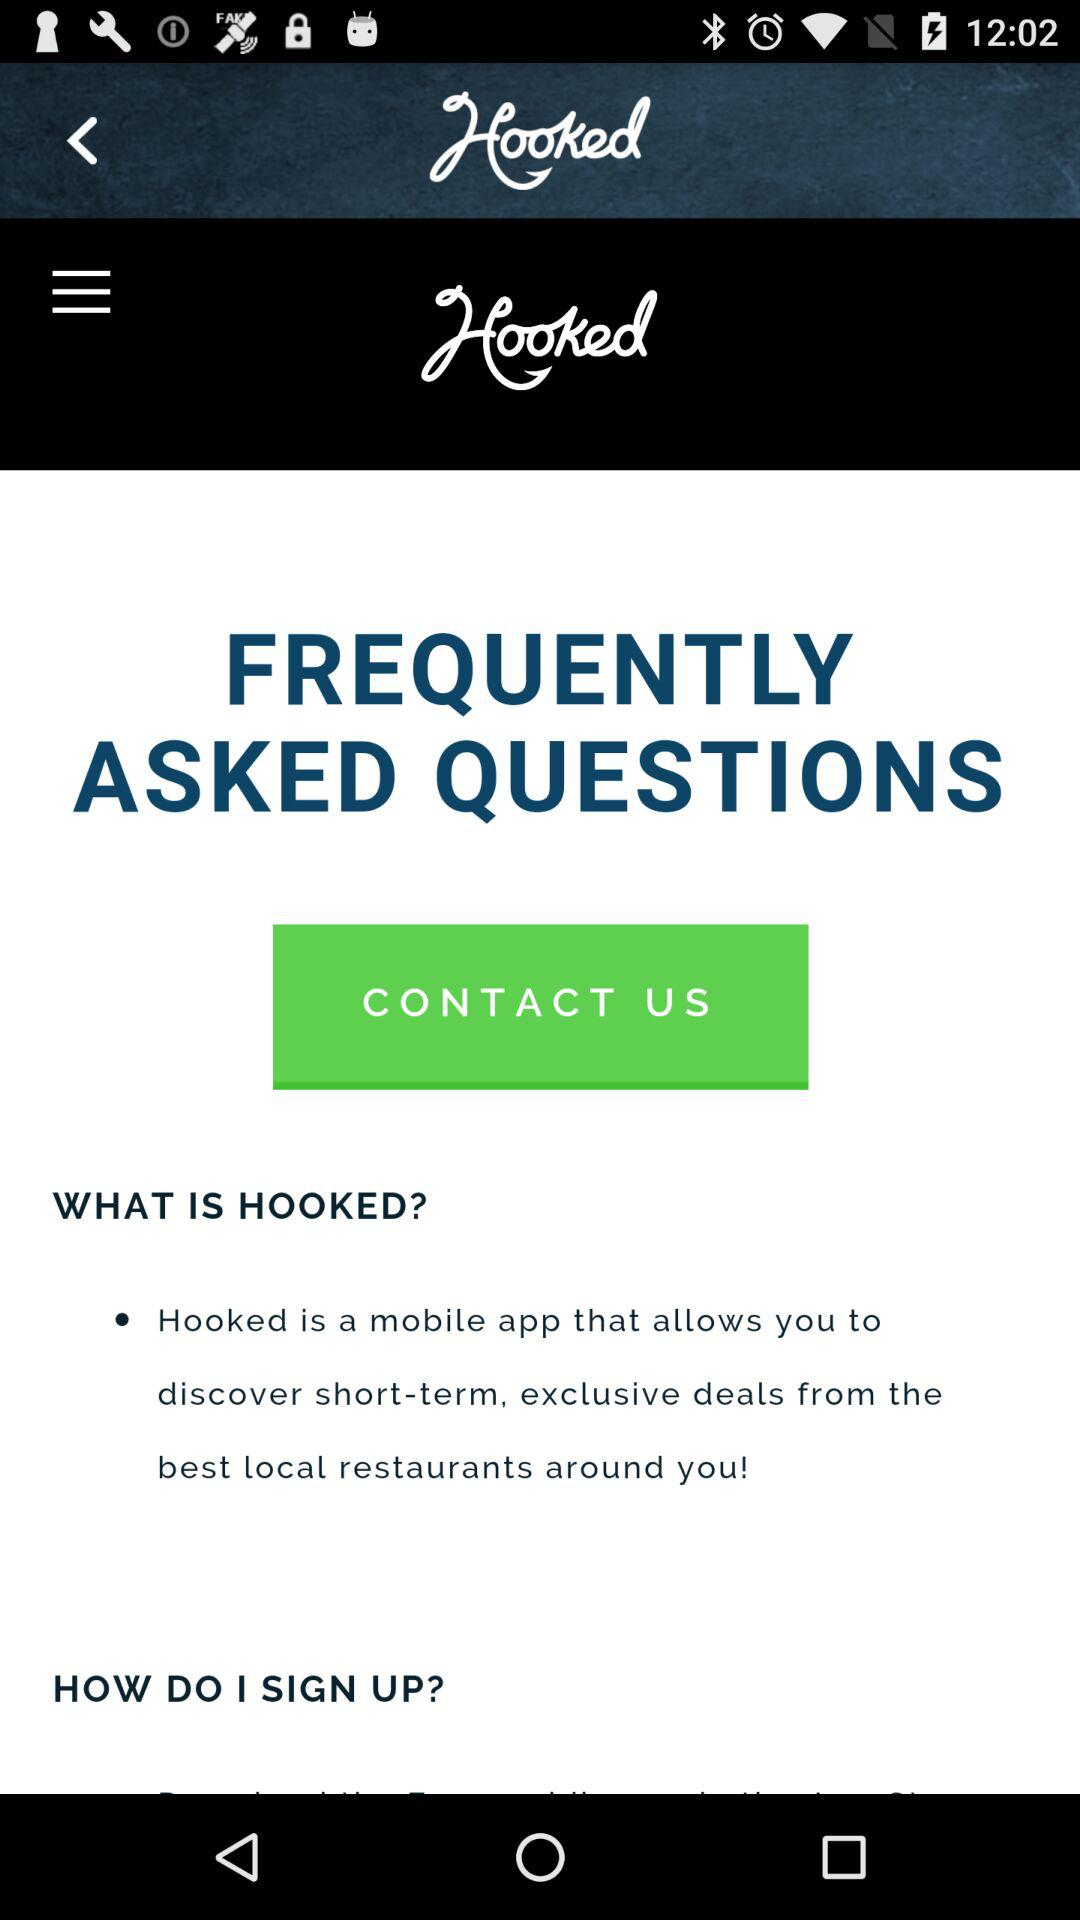What is the name of the application? The name of the application is "Hooked". 